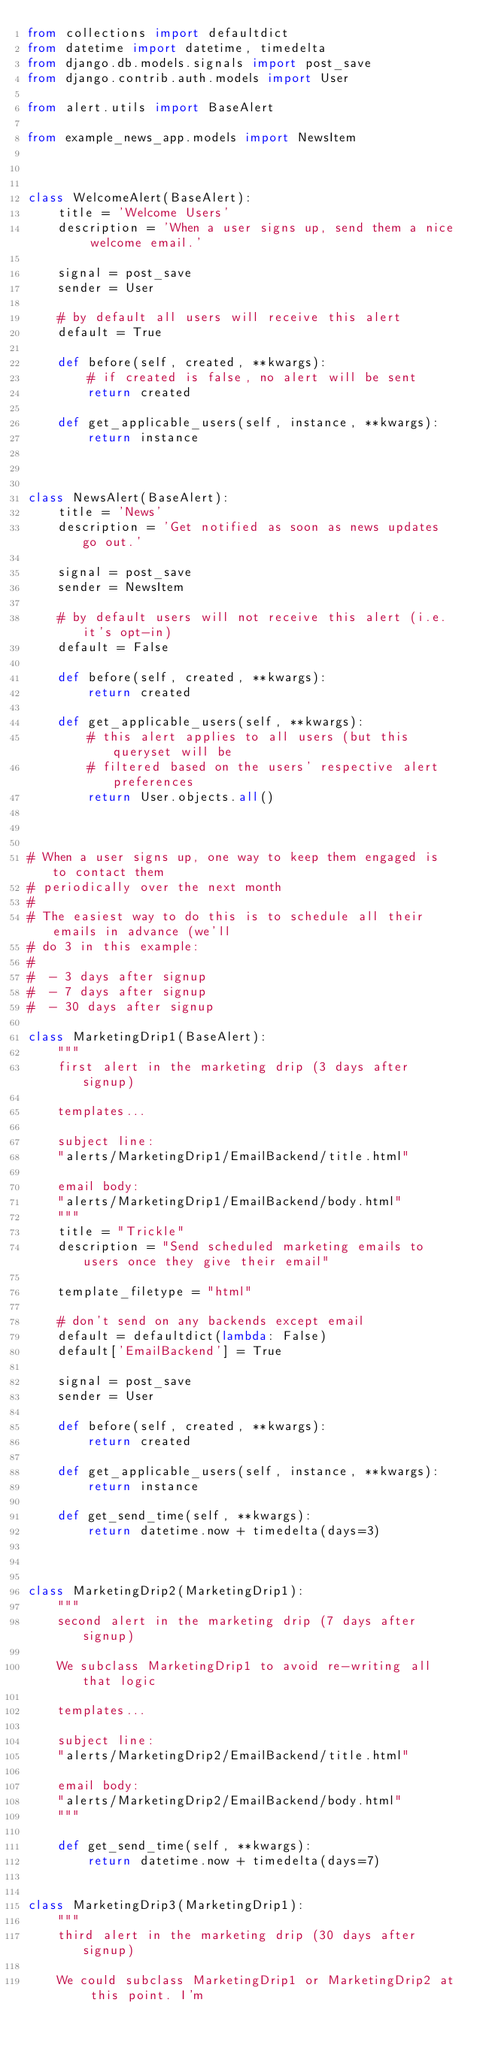<code> <loc_0><loc_0><loc_500><loc_500><_Python_>from collections import defaultdict
from datetime import datetime, timedelta
from django.db.models.signals import post_save
from django.contrib.auth.models import User

from alert.utils import BaseAlert

from example_news_app.models import NewsItem



class WelcomeAlert(BaseAlert):
    title = 'Welcome Users'
    description = 'When a user signs up, send them a nice welcome email.'
    
    signal = post_save
    sender = User
    
    # by default all users will receive this alert
    default = True
    
    def before(self, created, **kwargs):
        # if created is false, no alert will be sent
        return created
    
    def get_applicable_users(self, instance, **kwargs):
        return instance



class NewsAlert(BaseAlert):
    title = 'News'
    description = 'Get notified as soon as news updates go out.'
    
    signal = post_save
    sender = NewsItem
    
    # by default users will not receive this alert (i.e. it's opt-in)
    default = False
    
    def before(self, created, **kwargs):
        return created
    
    def get_applicable_users(self, **kwargs):
        # this alert applies to all users (but this queryset will be
        # filtered based on the users' respective alert preferences
        return User.objects.all()



# When a user signs up, one way to keep them engaged is to contact them
# periodically over the next month
#
# The easiest way to do this is to schedule all their emails in advance (we'll
# do 3 in this example:
#
#  - 3 days after signup
#  - 7 days after signup
#  - 30 days after signup 

class MarketingDrip1(BaseAlert):
    """
    first alert in the marketing drip (3 days after signup)
    
    templates...
    
    subject line: 
    "alerts/MarketingDrip1/EmailBackend/title.html"
    
    email body:
    "alerts/MarketingDrip1/EmailBackend/body.html"
    """
    title = "Trickle"
    description = "Send scheduled marketing emails to users once they give their email"
    
    template_filetype = "html"

    # don't send on any backends except email
    default = defaultdict(lambda: False)
    default['EmailBackend'] = True
    
    signal = post_save
    sender = User
    
    def before(self, created, **kwargs):
        return created
    
    def get_applicable_users(self, instance, **kwargs):
        return instance

    def get_send_time(self, **kwargs):
        return datetime.now + timedelta(days=3)
    


class MarketingDrip2(MarketingDrip1):
    """
    second alert in the marketing drip (7 days after signup)
    
    We subclass MarketingDrip1 to avoid re-writing all that logic
    
    templates...
    
    subject line: 
    "alerts/MarketingDrip2/EmailBackend/title.html"
    
    email body:
    "alerts/MarketingDrip2/EmailBackend/body.html"
    """

    def get_send_time(self, **kwargs):
        return datetime.now + timedelta(days=7)
    

class MarketingDrip3(MarketingDrip1):
    """
    third alert in the marketing drip (30 days after signup)
    
    We could subclass MarketingDrip1 or MarketingDrip2 at this point. I'm</code> 